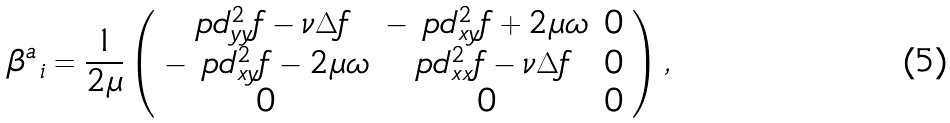Convert formula to latex. <formula><loc_0><loc_0><loc_500><loc_500>\beta ^ { a } _ { \ i } = \frac { 1 } { 2 \mu } \left ( \begin{array} { c c c } \ p d ^ { 2 } _ { y y } f - \nu \Delta f & - \ p d ^ { 2 } _ { x y } f + 2 \mu \omega & 0 \\ - \ p d ^ { 2 } _ { x y } f - 2 \mu \omega & \ p d ^ { 2 } _ { x x } f - \nu \Delta f & 0 \\ 0 & 0 & 0 \end{array} \right ) ,</formula> 